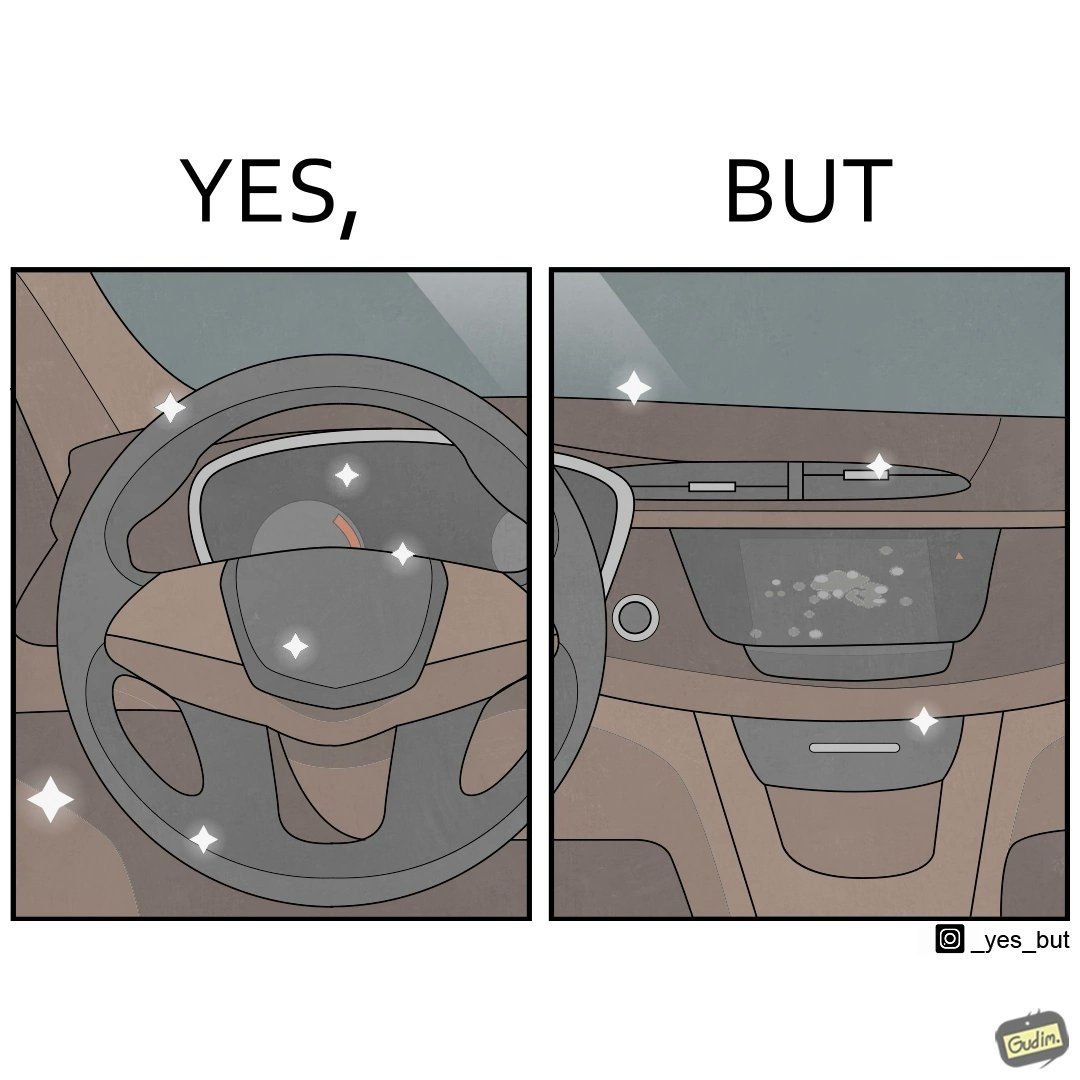What is the satirical meaning behind this image? The dashboard and steering wheel of the car look sparkling clean, but the greasy fingerprints on the touch panel reduce the appeal of the dashboard. 